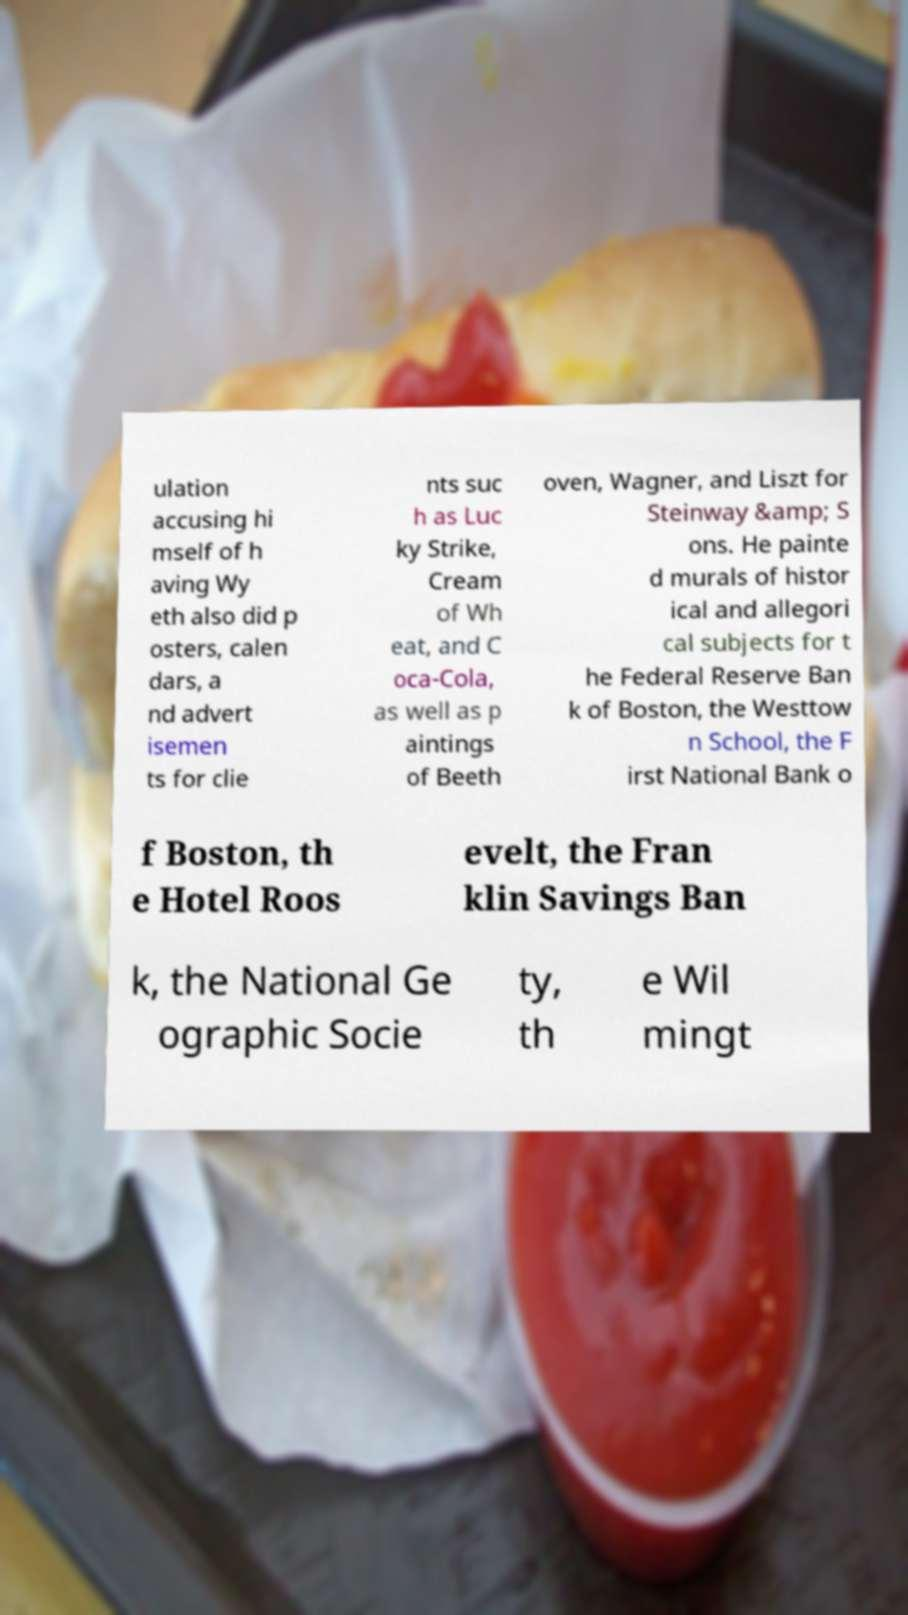For documentation purposes, I need the text within this image transcribed. Could you provide that? ulation accusing hi mself of h aving Wy eth also did p osters, calen dars, a nd advert isemen ts for clie nts suc h as Luc ky Strike, Cream of Wh eat, and C oca-Cola, as well as p aintings of Beeth oven, Wagner, and Liszt for Steinway &amp; S ons. He painte d murals of histor ical and allegori cal subjects for t he Federal Reserve Ban k of Boston, the Westtow n School, the F irst National Bank o f Boston, th e Hotel Roos evelt, the Fran klin Savings Ban k, the National Ge ographic Socie ty, th e Wil mingt 